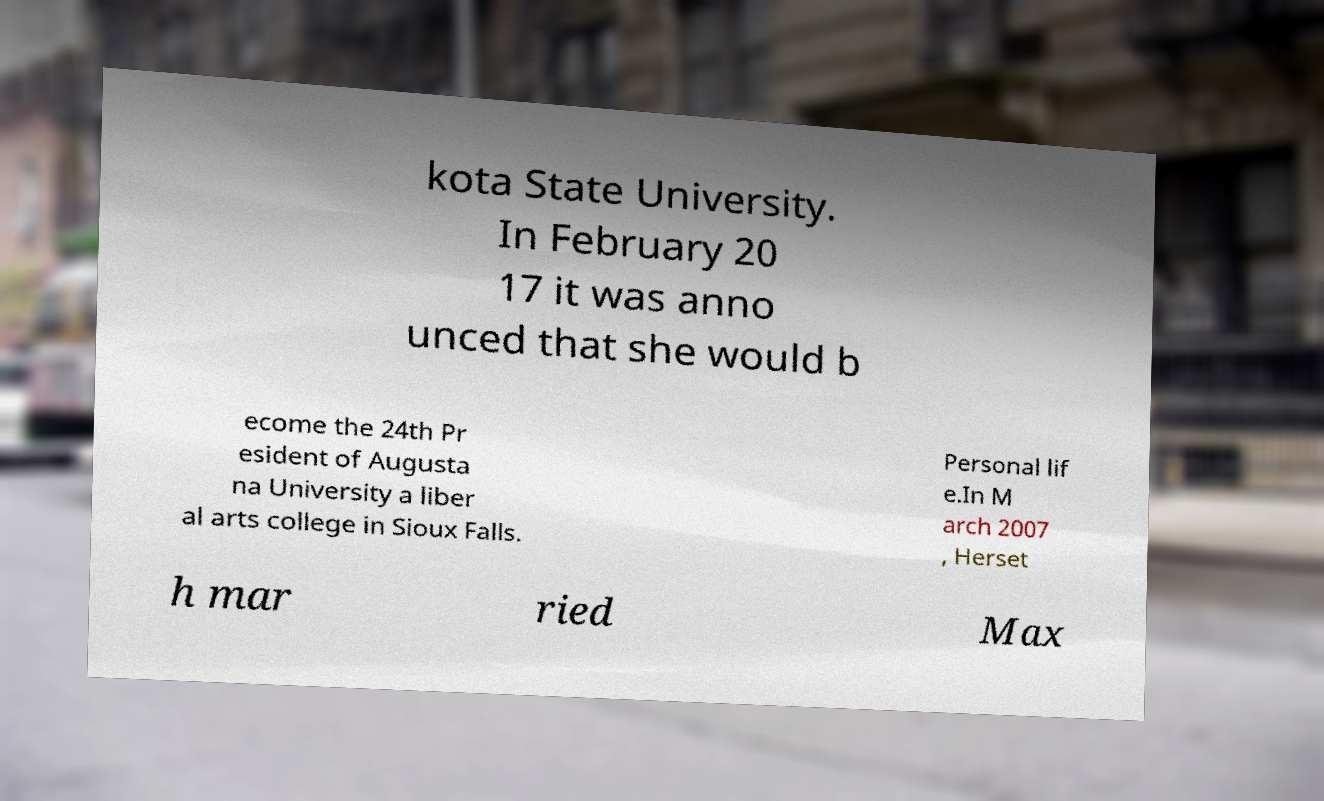Could you assist in decoding the text presented in this image and type it out clearly? kota State University. In February 20 17 it was anno unced that she would b ecome the 24th Pr esident of Augusta na University a liber al arts college in Sioux Falls. Personal lif e.In M arch 2007 , Herset h mar ried Max 